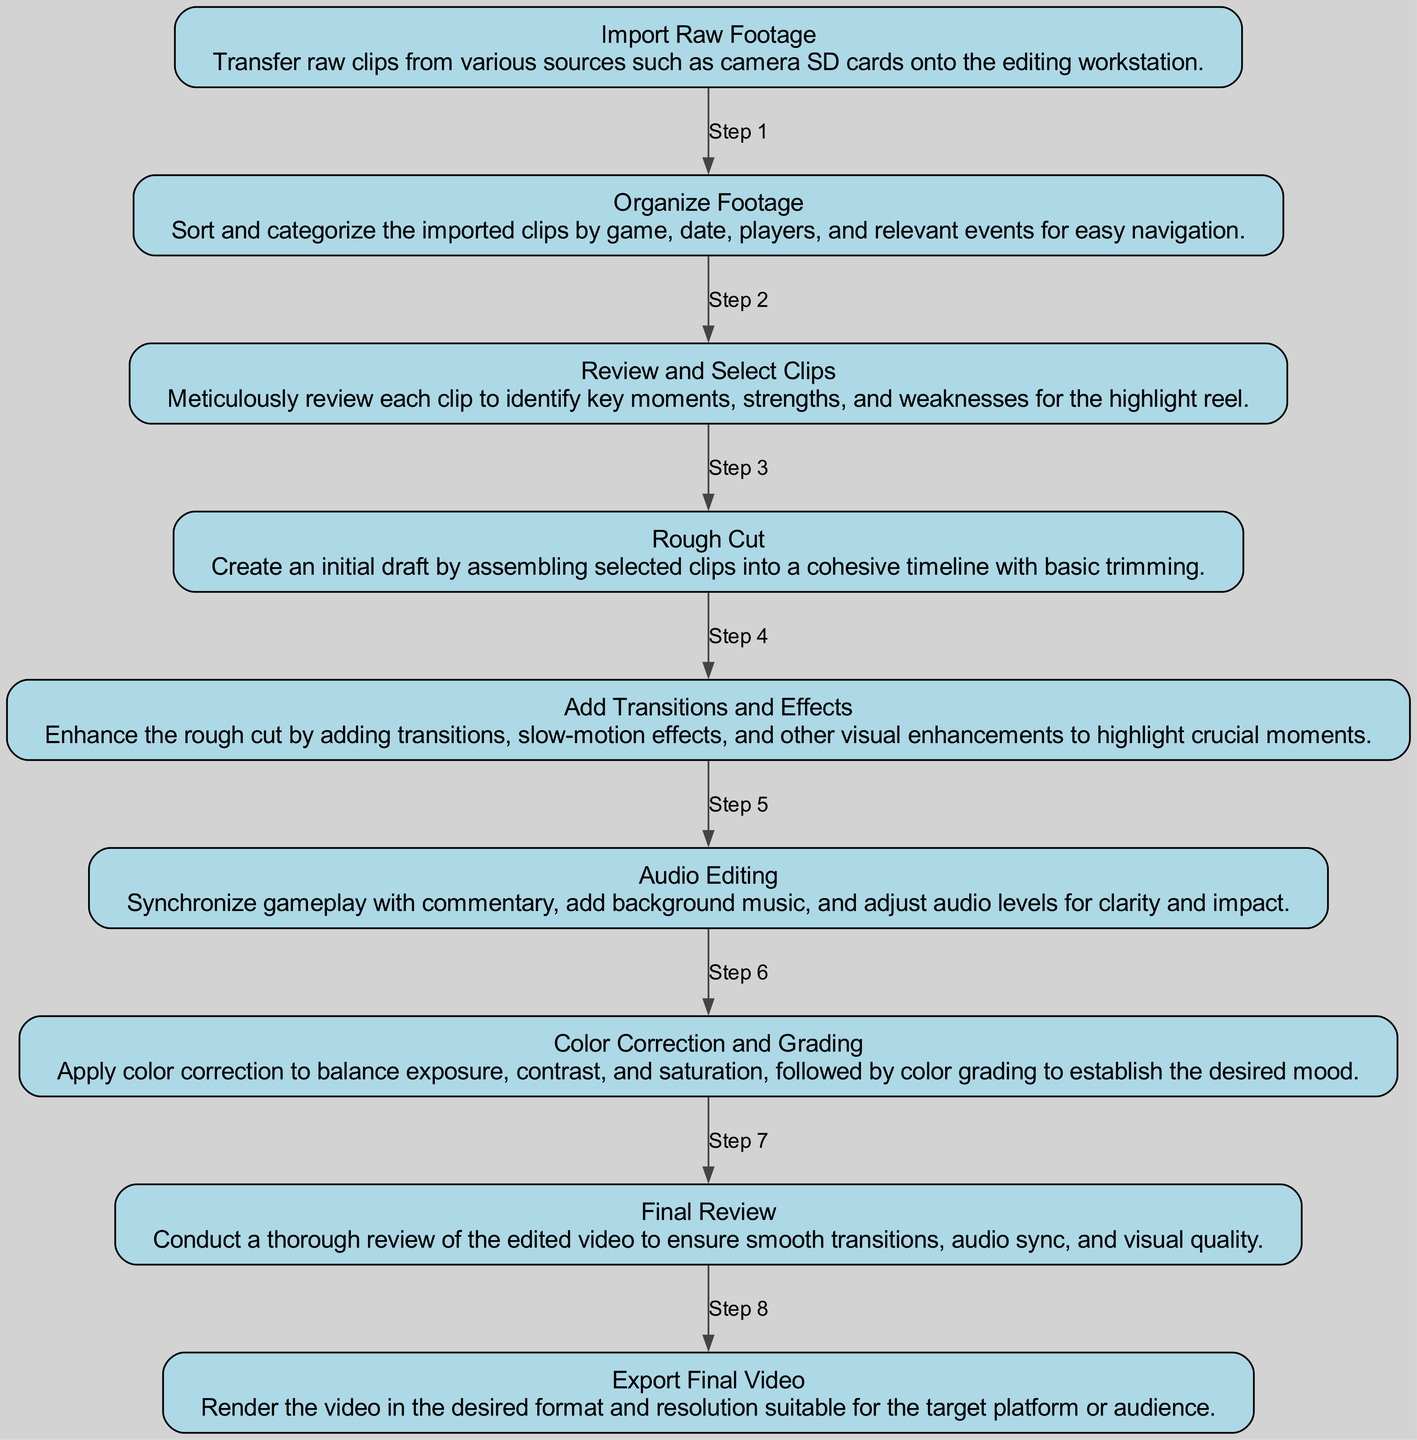What is the first step in the video editing process? The diagram indicates the flow starts with the "Import Raw Footage" step, which is shown at the top of the flow chart as the initial node.
Answer: Import Raw Footage How many nodes are present in the diagram? By counting all unique steps listed in the diagram, there are nine nodes that represent different stages in the editing process.
Answer: Nine What is the last step before the final output? Referring to the flow, the step just before "Export Final Video" is "Final Review," which is the last editing step to ensure the video quality.
Answer: Final Review Which step directly follows "Review and Select Clips"? The diagram shows that the step that directly follows "Review and Select Clips" is "Rough Cut," indicating a progression to refining the selected moments.
Answer: Rough Cut What type of editing occurs after adding transitions and effects? The flow chart clearly indicates that "Audio Editing" occurs next, emphasizing the importance of synchronizing audio with the visuals after visual enhancements are made.
Answer: Audio Editing How many steps involve color adjustments? Analyzing the diagram, there is one specific step labeled "Color Correction and Grading," which covers the complete process of adjusting colors in the video.
Answer: One What are the key objectives mentioned in the "Add Transitions and Effects" step? The step mentions enhancing the rough cut by adding transitions and effects, specifically focusing on highlighting crucial moments, which is a central goal of this action.
Answer: Highlight crucial moments What is the relationship between "Rough Cut" and "Add Transitions and Effects"? The flow indicates that "Add Transitions and Effects" is the subsequent step that follows the "Rough Cut," implying a sequential relationship of building upon the initial draft.
Answer: Sequential relationship Which step emphasizes organizing clips? The flow chart distinctly identifies "Organize Footage" as the step dedicated to sorting and categorizing clips, which is critical for efficient editing.
Answer: Organize Footage 